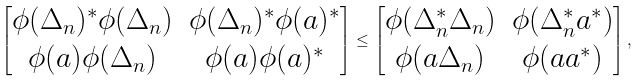<formula> <loc_0><loc_0><loc_500><loc_500>\begin{bmatrix} \phi ( \Delta _ { n } ) ^ { * } \phi ( \Delta _ { n } ) & \phi ( \Delta _ { n } ) ^ { * } \phi ( a ) ^ { * } \\ \phi ( a ) \phi ( \Delta _ { n } ) & \phi ( a ) \phi ( a ) ^ { * } \end{bmatrix} \leq \begin{bmatrix} \phi ( \Delta _ { n } ^ { * } \Delta _ { n } ) & \phi ( \Delta _ { n } ^ { * } a ^ { * } ) \\ \phi ( a \Delta _ { n } ) & \phi ( a a ^ { * } ) \end{bmatrix} ,</formula> 